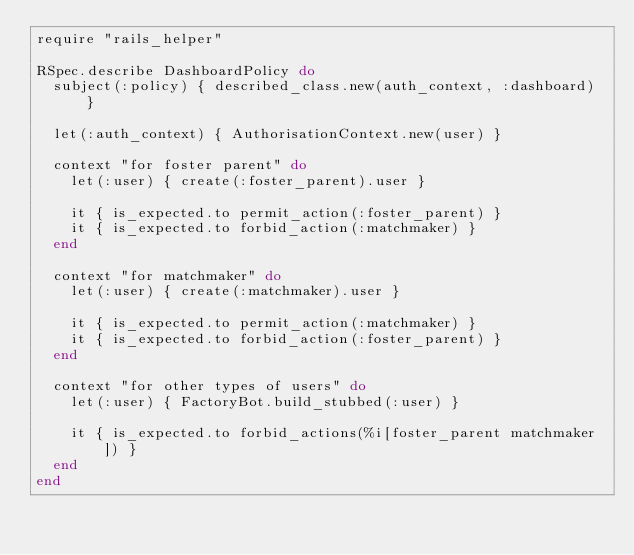<code> <loc_0><loc_0><loc_500><loc_500><_Ruby_>require "rails_helper"

RSpec.describe DashboardPolicy do
  subject(:policy) { described_class.new(auth_context, :dashboard) }

  let(:auth_context) { AuthorisationContext.new(user) }

  context "for foster parent" do
    let(:user) { create(:foster_parent).user }

    it { is_expected.to permit_action(:foster_parent) }
    it { is_expected.to forbid_action(:matchmaker) }
  end

  context "for matchmaker" do
    let(:user) { create(:matchmaker).user }

    it { is_expected.to permit_action(:matchmaker) }
    it { is_expected.to forbid_action(:foster_parent) }
  end

  context "for other types of users" do
    let(:user) { FactoryBot.build_stubbed(:user) }

    it { is_expected.to forbid_actions(%i[foster_parent matchmaker]) }
  end
end
</code> 